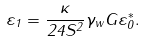<formula> <loc_0><loc_0><loc_500><loc_500>\varepsilon _ { 1 } = \frac { \kappa } { 2 4 S ^ { 2 } } \gamma _ { w } G \varepsilon _ { 0 } ^ { * } .</formula> 